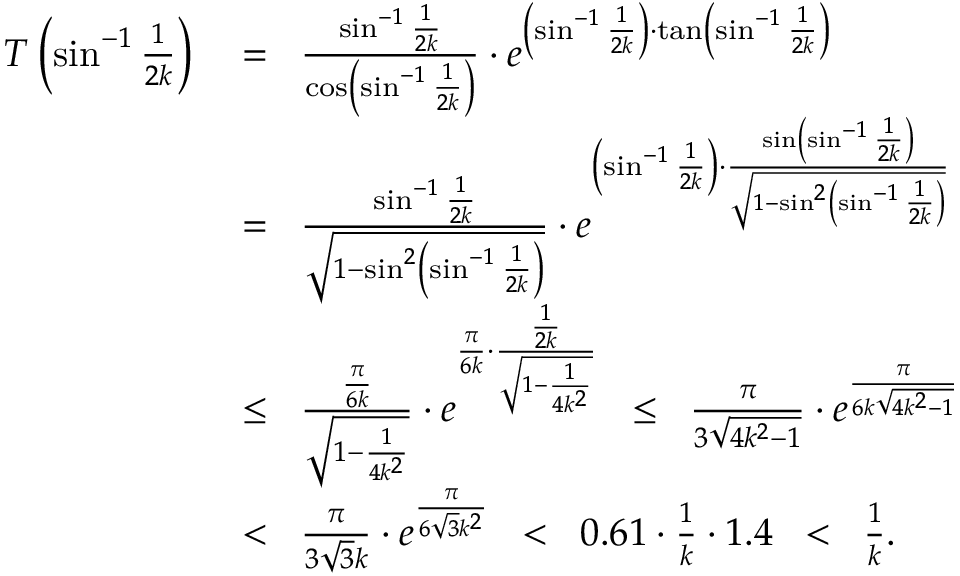Convert formula to latex. <formula><loc_0><loc_0><loc_500><loc_500>\begin{array} { r l } { T \left ( \sin ^ { - 1 } \frac { 1 } { 2 k } \right ) \, } & { = \, \frac { \sin ^ { - 1 } \frac { 1 } { 2 k } } { \cos \left ( \sin ^ { - 1 } \frac { 1 } { 2 k } \right ) } \cdot e ^ { \left ( \sin ^ { - 1 } \frac { 1 } { 2 k } \right ) \cdot \tan \left ( \sin ^ { - 1 } \frac { 1 } { 2 k } \right ) } } \\ & { = \, \frac { \sin ^ { - 1 } \frac { 1 } { 2 k } } { \sqrt { 1 - \sin ^ { 2 } \left ( \sin ^ { - 1 } \frac { 1 } { 2 k } \right ) } } \cdot e ^ { \left ( \sin ^ { - 1 } \frac { 1 } { 2 k } \right ) \cdot \frac { \sin \left ( \sin ^ { - 1 } \frac { 1 } { 2 k } \right ) } { \sqrt { { 1 - \sin ^ { 2 } \left ( \sin ^ { - 1 } \frac { 1 } { 2 k } \right ) } } } } } \\ & { \leq \, \frac { \frac { \pi } { 6 k } } { \sqrt { 1 - \frac { 1 } { 4 k ^ { 2 } } } } \cdot e ^ { \frac { \pi } { 6 k } \cdot \frac { \frac { 1 } { 2 k } } { \sqrt { { 1 - \frac { 1 } { 4 k ^ { 2 } } } } } } \, \leq \, \frac { \pi } { 3 \sqrt { 4 k ^ { 2 } - 1 } } \cdot e ^ { \frac { \pi } { 6 k \sqrt { { 4 k ^ { 2 } - 1 } } } } } \\ & { < \, \frac { \pi } { 3 \sqrt { 3 } k } \cdot e ^ { \frac { \pi } { 6 \sqrt { 3 } k ^ { 2 } } } \, < \, 0 . 6 1 \cdot \frac { 1 } { k } \cdot 1 . 4 \, < \, \frac { 1 } { k } . } \end{array}</formula> 